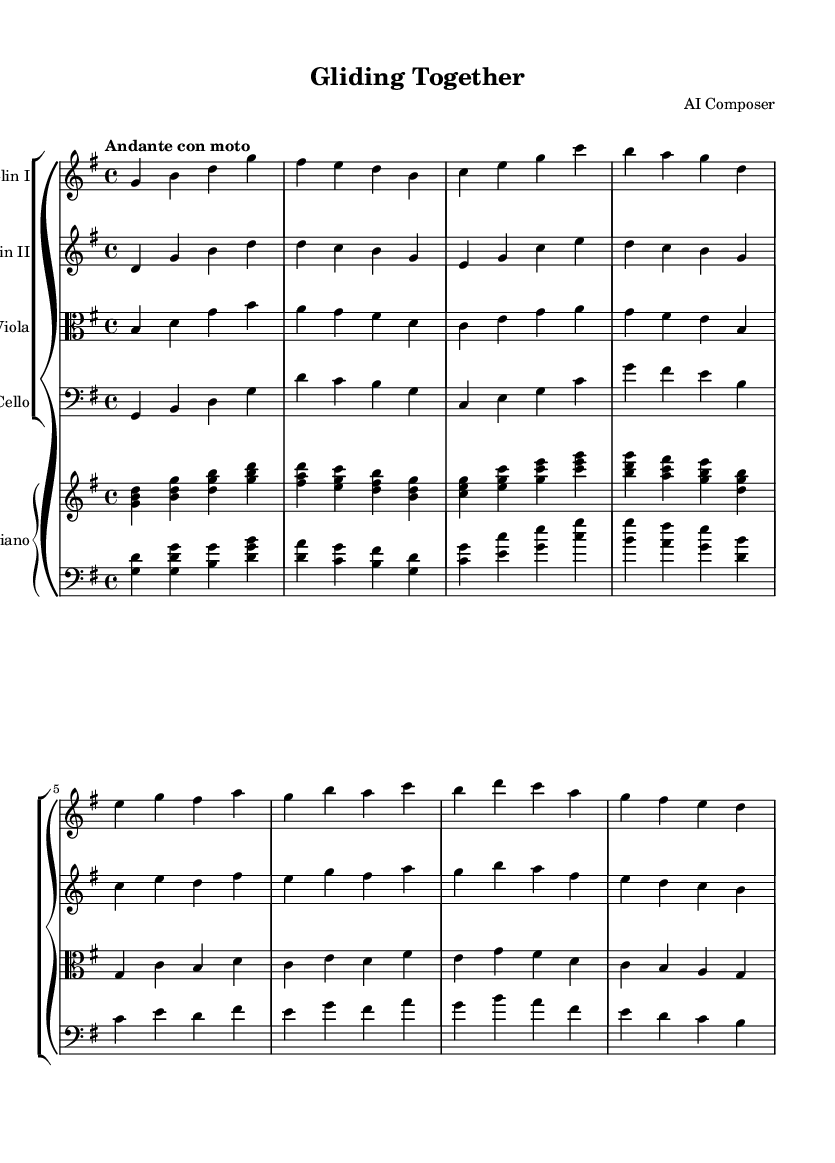What is the key signature of this music? The key signature is G major, which has one sharp (F#). This can be determined by looking at the key signature indicated at the beginning of the sheet music.
Answer: G major What is the time signature of this piece? The time signature is 4/4, which means there are four beats in each measure and a quarter note gets one beat. This is found at the beginning of the sheet music where time signatures are indicated.
Answer: 4/4 What is the tempo marking for this composition? The tempo marking is "Andante con moto," which indicates a moderately slow and flowing pace. This marking is specified at the beginning of the sheet music.
Answer: Andante con moto How many instrumental parts are written in this sheet music? There are five instrumental parts: two violins, viola, cello, and piano. This is identified by counting the staves in the Grand Staff segment of the score.
Answer: Five What is the lowest instrument featured in this score? The lowest instrument is the cello, which is indicated by the bass clef and its position in the Grand Staff. The cello typically plays in lower registers compared to other string instruments in this arrangement.
Answer: Cello Why is this piece categorized as "Romantic" music? This piece can be categorized as "Romantic" because it emphasizes emotional expression and features rich harmonic language, as seen in the interplay between the strings and piano that suggests lyrical themes and celebrates teamwork. Romantic music often focuses on individual and collective emotional experiences.
Answer: Emotional expression 